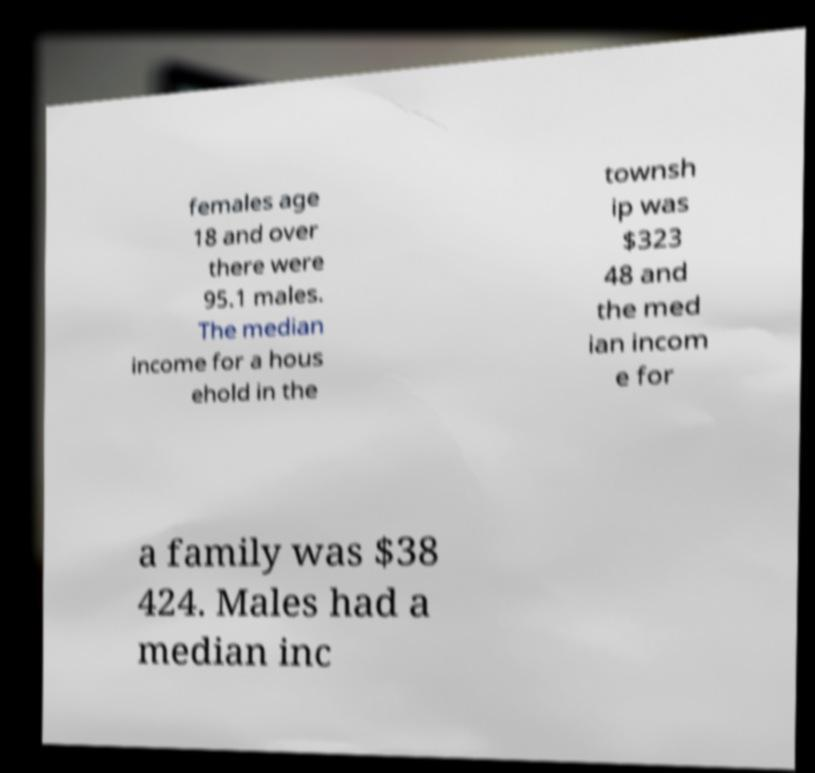For documentation purposes, I need the text within this image transcribed. Could you provide that? females age 18 and over there were 95.1 males. The median income for a hous ehold in the townsh ip was $323 48 and the med ian incom e for a family was $38 424. Males had a median inc 